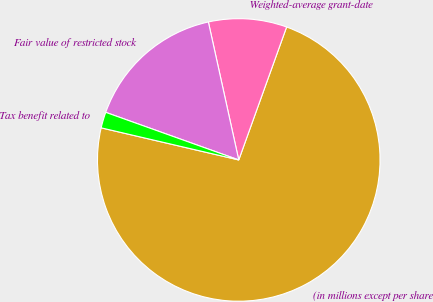Convert chart. <chart><loc_0><loc_0><loc_500><loc_500><pie_chart><fcel>(in millions except per share<fcel>Weighted-average grant-date<fcel>Fair value of restricted stock<fcel>Tax benefit related to<nl><fcel>73.15%<fcel>8.95%<fcel>16.08%<fcel>1.82%<nl></chart> 